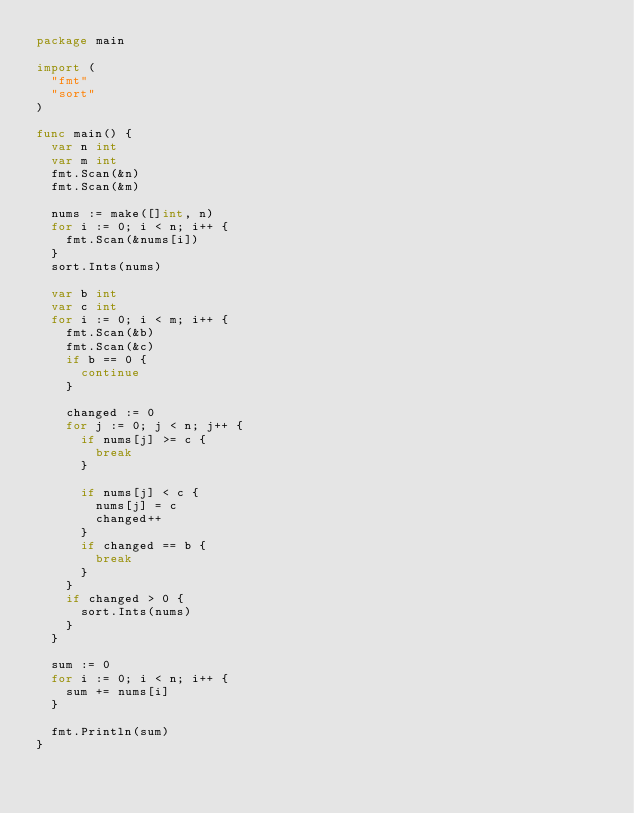<code> <loc_0><loc_0><loc_500><loc_500><_Go_>package main

import (
	"fmt"
	"sort"
)

func main() {
	var n int
	var m int
	fmt.Scan(&n)
	fmt.Scan(&m)

	nums := make([]int, n)
	for i := 0; i < n; i++ {
		fmt.Scan(&nums[i])
	}
	sort.Ints(nums)

	var b int
	var c int
	for i := 0; i < m; i++ {
		fmt.Scan(&b)
		fmt.Scan(&c)
		if b == 0 {
			continue
		}

		changed := 0
		for j := 0; j < n; j++ {
			if nums[j] >= c {
				break
			}

			if nums[j] < c {
				nums[j] = c
				changed++
			}
			if changed == b {
				break
			}
		}
		if changed > 0 {
			sort.Ints(nums)
		}
	}

	sum := 0
	for i := 0; i < n; i++ {
		sum += nums[i]
	}

	fmt.Println(sum)
}
</code> 